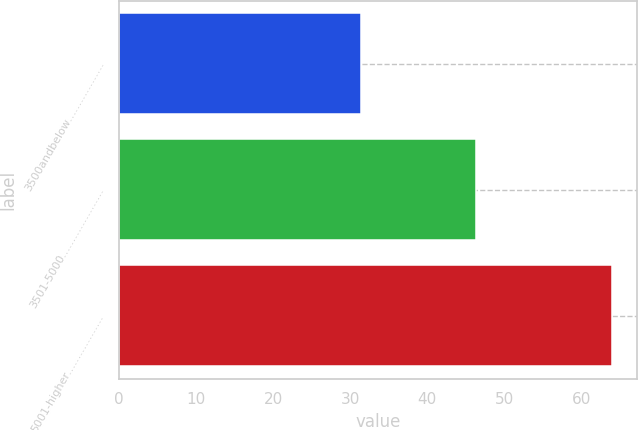Convert chart to OTSL. <chart><loc_0><loc_0><loc_500><loc_500><bar_chart><fcel>3500andbelow………………<fcel>3501-5000…………………<fcel>5001-higher………………<nl><fcel>31.39<fcel>46.41<fcel>64.07<nl></chart> 